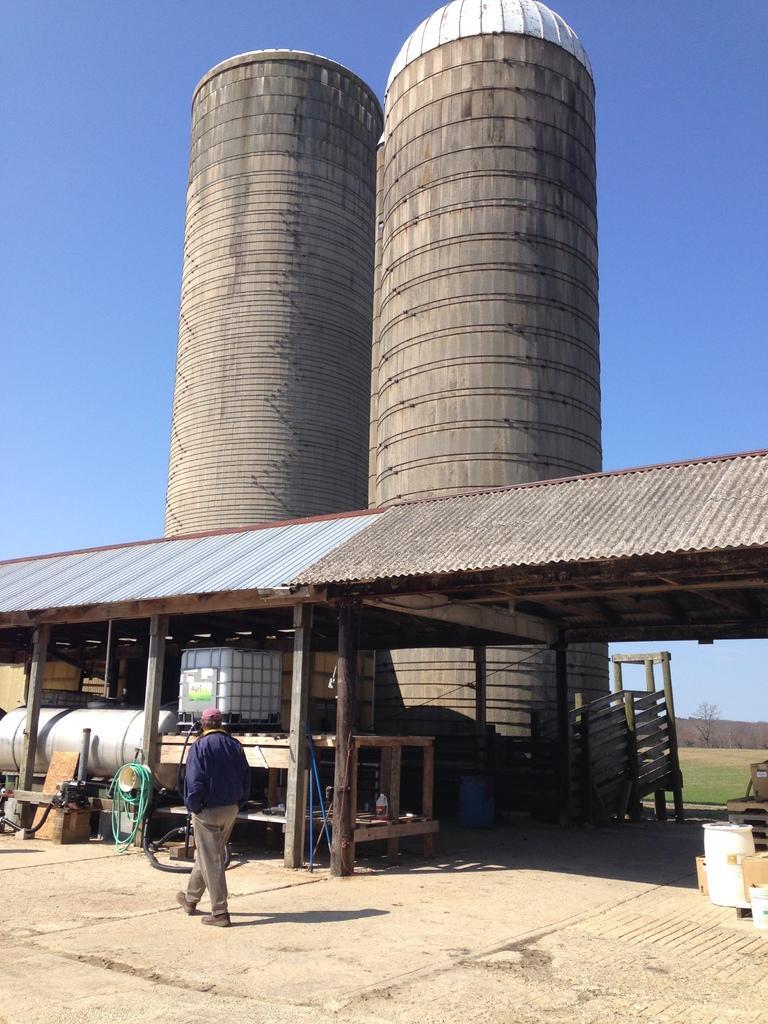Please provide a concise description of this image. This picture is clicked outside. In the foreground we can see a person walking on the ground and we can see the table and many other objects are placed on the ground. In the center we can see a gazebo and the towers and we can see the grass, wooden planks and some other items. In the background we can see the sky. 